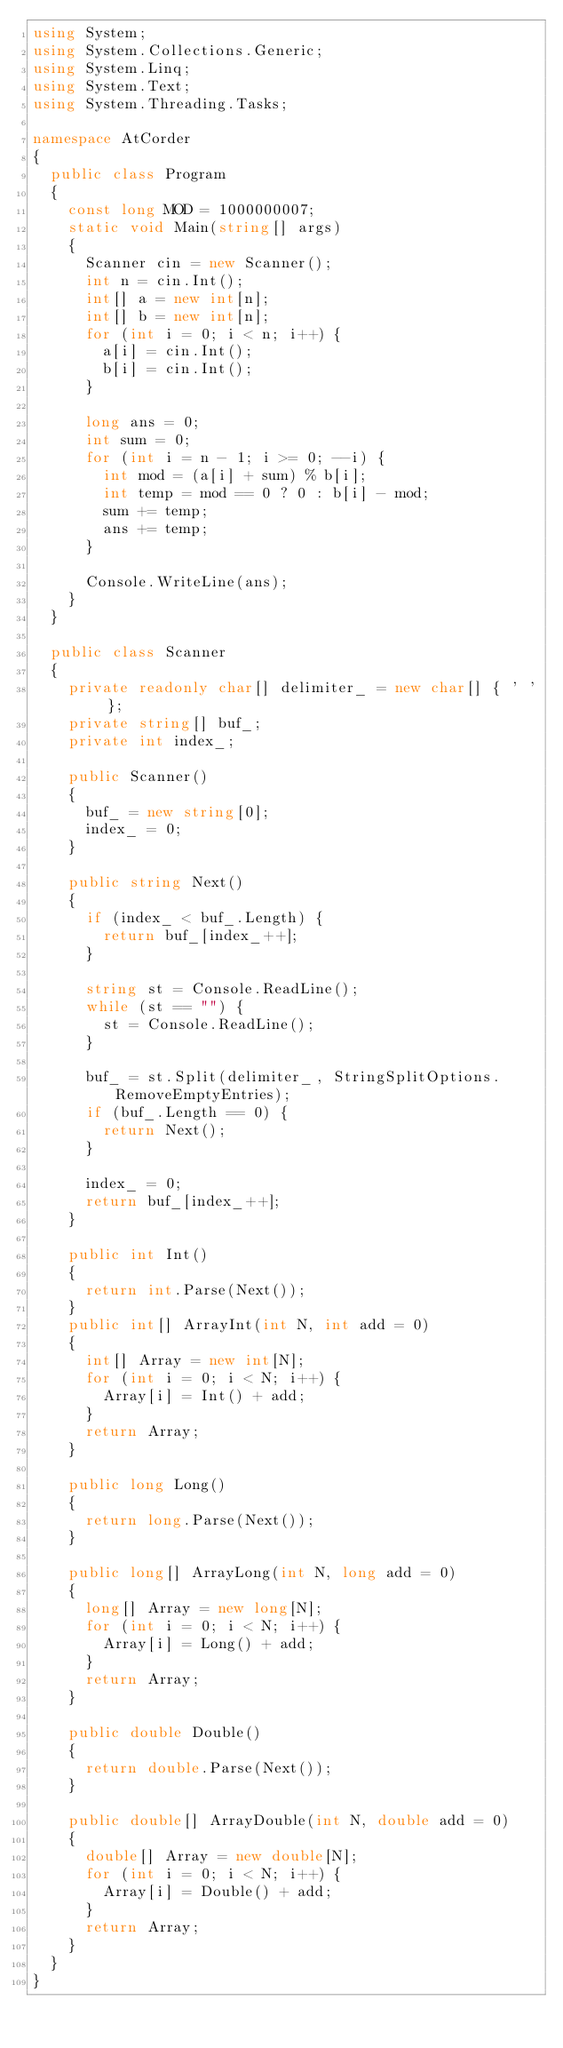<code> <loc_0><loc_0><loc_500><loc_500><_C#_>using System;
using System.Collections.Generic;
using System.Linq;
using System.Text;
using System.Threading.Tasks;

namespace AtCorder
{
	public class Program
	{
		const long MOD = 1000000007;
		static void Main(string[] args)
		{
			Scanner cin = new Scanner();
			int n = cin.Int();
			int[] a = new int[n];
			int[] b = new int[n];
			for (int i = 0; i < n; i++) {
				a[i] = cin.Int();
				b[i] = cin.Int();
			}

			long ans = 0;
			int sum = 0;
			for (int i = n - 1; i >= 0; --i) {
				int mod = (a[i] + sum) % b[i];
				int temp = mod == 0 ? 0 : b[i] - mod;
				sum += temp;
				ans += temp;
			}

			Console.WriteLine(ans);
		}
	}

	public class Scanner
	{
		private readonly char[] delimiter_ = new char[] { ' ' };
		private string[] buf_;
		private int index_;
		
		public Scanner()
		{
			buf_ = new string[0];
			index_ = 0;
		}

		public string Next()
		{
			if (index_ < buf_.Length) {
				return buf_[index_++];
			}

			string st = Console.ReadLine();
			while (st == "") {
				st = Console.ReadLine();
			}

			buf_ = st.Split(delimiter_, StringSplitOptions.RemoveEmptyEntries);
			if (buf_.Length == 0) {
				return Next();
			}

			index_ = 0;
			return buf_[index_++];
		}

		public int Int()
		{
			return int.Parse(Next());
		}
		public int[] ArrayInt(int N, int add = 0)
		{
			int[] Array = new int[N];
			for (int i = 0; i < N; i++) {
				Array[i] = Int() + add;
			}
			return Array;
		}

		public long Long()
		{
			return long.Parse(Next());
		}

		public long[] ArrayLong(int N, long add = 0)
		{
			long[] Array = new long[N];
			for (int i = 0; i < N; i++) {
				Array[i] = Long() + add;
			}
			return Array;
		}

		public double Double()
		{
			return double.Parse(Next());
		}

		public double[] ArrayDouble(int N, double add = 0)
		{
			double[] Array = new double[N];
			for (int i = 0; i < N; i++) {
				Array[i] = Double() + add;
			}
			return Array;
		}
	}
}
</code> 